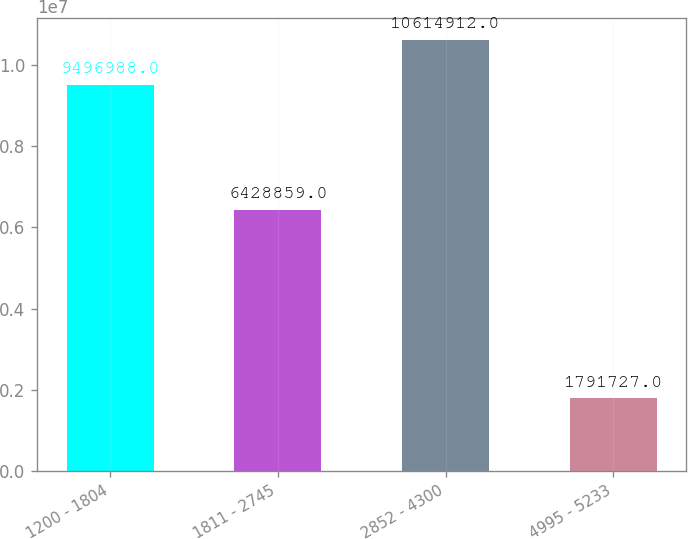<chart> <loc_0><loc_0><loc_500><loc_500><bar_chart><fcel>1200 - 1804<fcel>1811 - 2745<fcel>2852 - 4300<fcel>4995 - 5233<nl><fcel>9.49699e+06<fcel>6.42886e+06<fcel>1.06149e+07<fcel>1.79173e+06<nl></chart> 